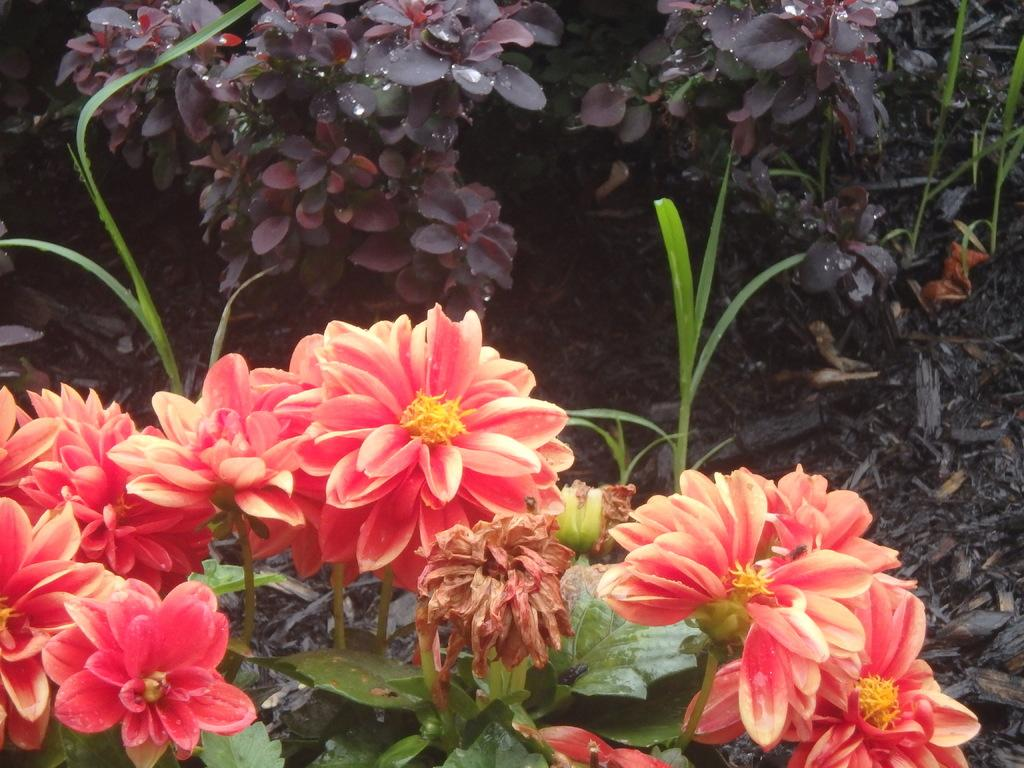What types of plants can be seen in the image? There are plants with flowers and plants with leaves in the image. Can you describe the plants in the background? The background of the image includes plants with leaves. What is the vegetation on the land in the image? There is grass on the land in the image. How many beggars are visible in the image? There are no beggars present in the image. What type of glove is being used to water the plants in the image? There is no glove visible in the image, and no one is watering the plants. 